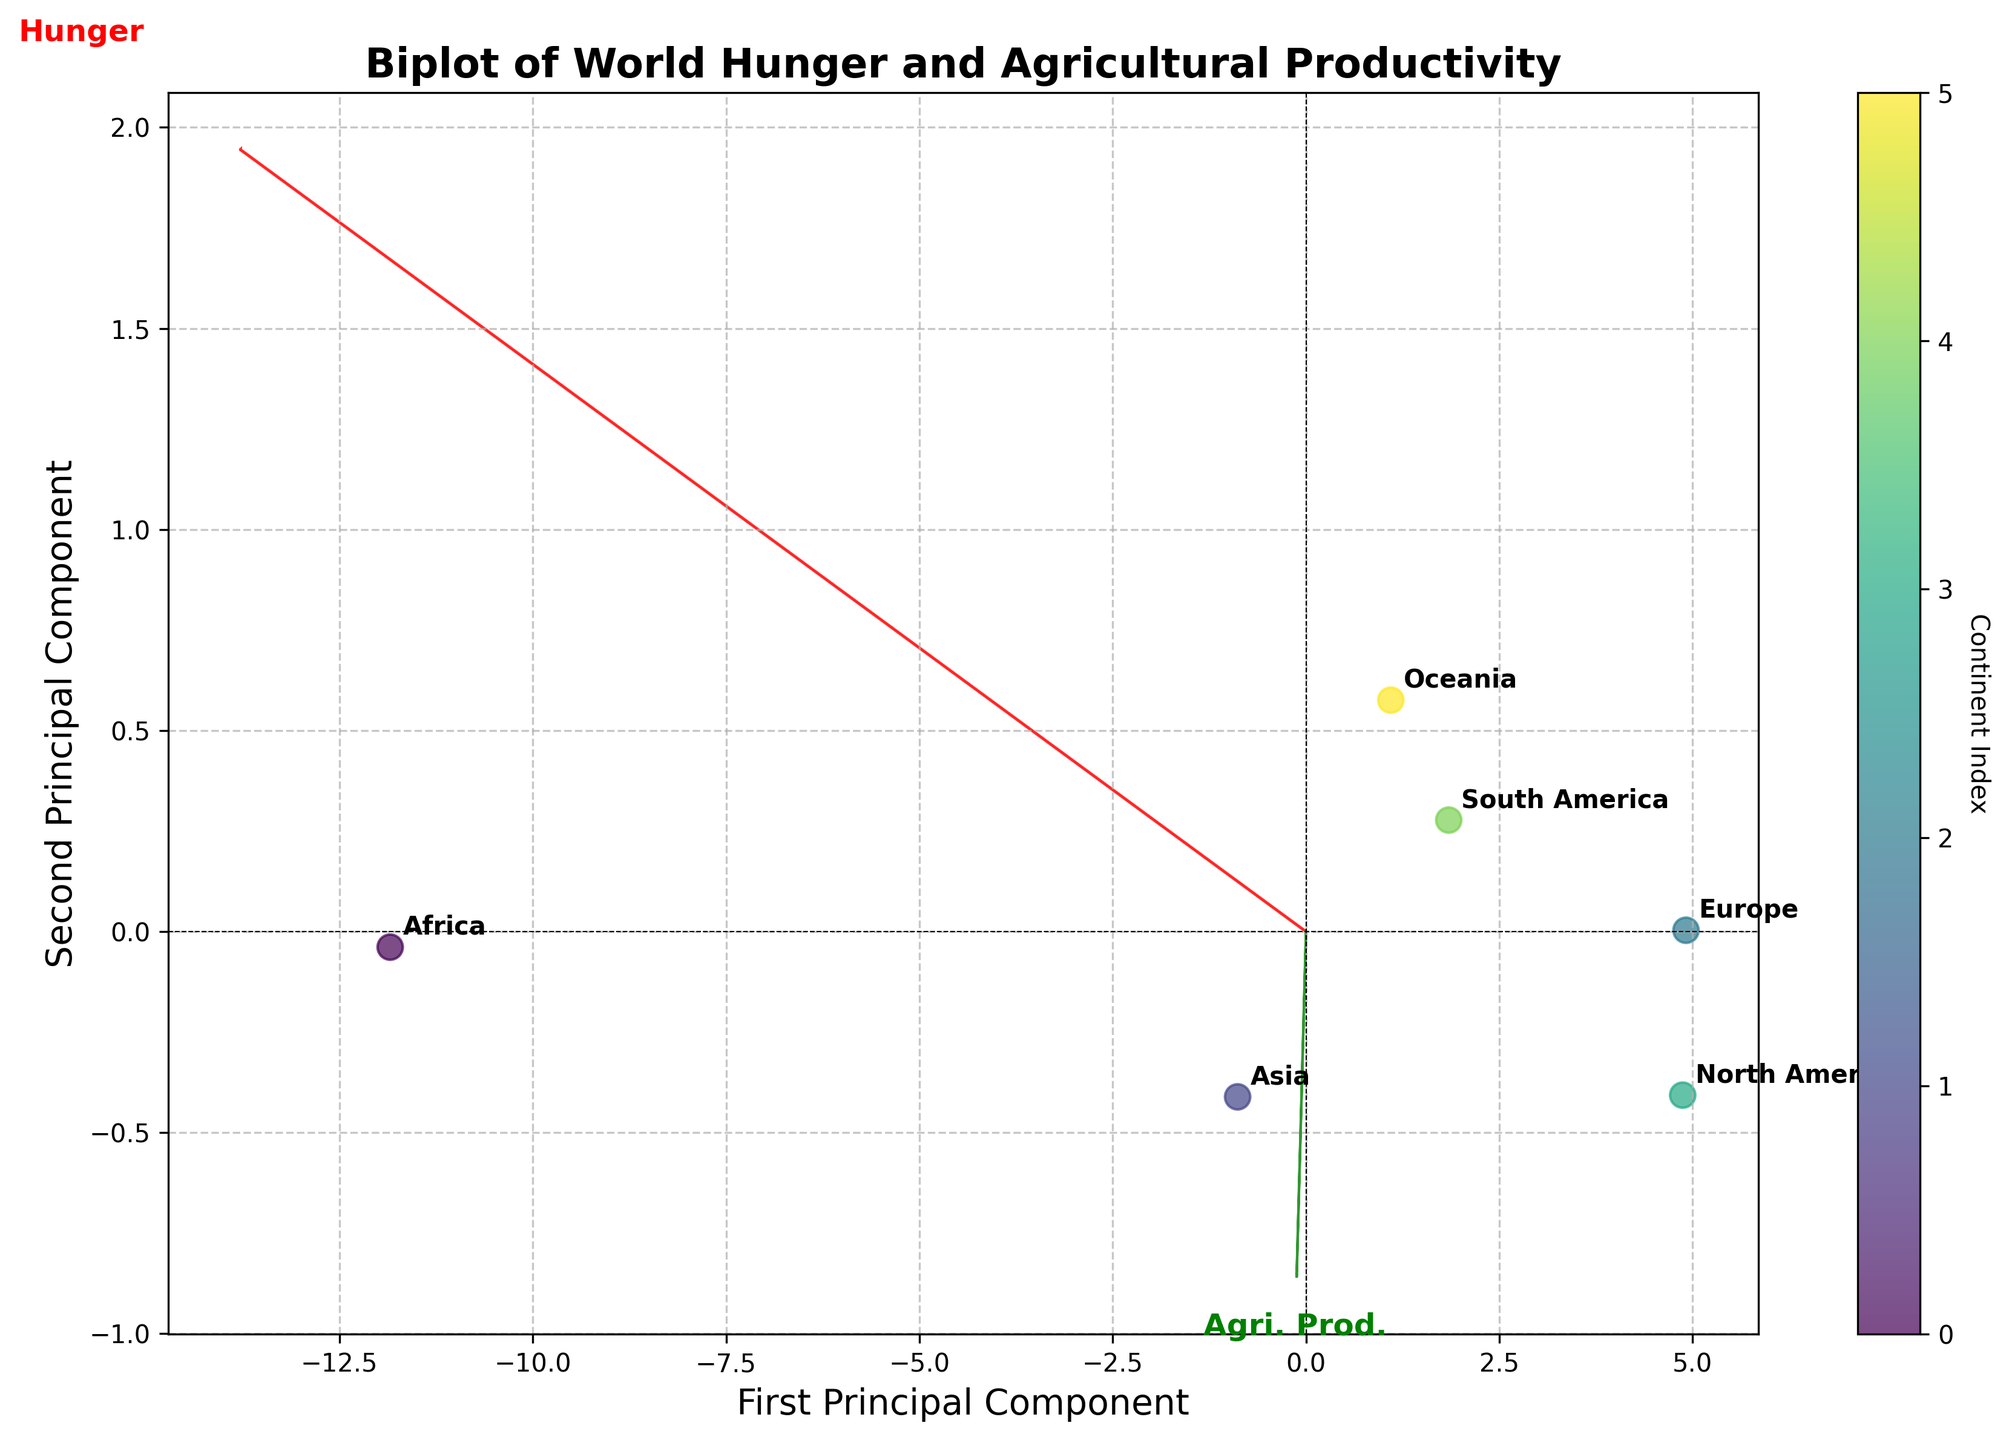How many continents are represented in the biplot? There are six data points in the scatter plot, each annotated with a continent label. Therefore, six continents are represented.
Answer: Six Which principal component explains the most variance in the data? The first principal component is always the one that explains the most variance in the data, as implied by its position on the x-axis.
Answer: First Principal Component Which continent has the lowest agricultural productivity? The position of the data points on the biplot shows that Africa is the farthest to the left along the "Agri. Prod." axis, indicating the lowest agricultural productivity.
Answer: Africa Which two features are represented by the vectors in the biplot? The arrows labeled "Hunger" and "Agri. Prod." represent the two features of the dataset. These arrows indicate loading directions of these variables.
Answer: Hunger and Agricultural Productivity If you walk along the 'Hunger' vector from the origin, which continent do you encounter first? Following the direction of the 'Hunger' vector from the origin, the first continent data point you come across is Africa.
Answer: Africa Which continent has the highest irrigation coverage and is this reflected in its position on the biplot? According to the biplot, Asia, which is positioned in the upper region indicating higher agricultural productivity, has the highest irrigation coverage.
Answer: Asia How does South America compare to Europe in terms of hunger prevalence based on the biplot? The difference in the positions of South America and Europe along the 'Hunger' vector shows that South America has a higher hunger prevalence compared to Europe.
Answer: South America has higher hunger prevalence than Europe What does the color of the scatter points represent? The color bar labeled 'Continent Index' indicates that the colors of the scatter points represent different continent indices, distinguishing each continent visually.
Answer: Continent Index Is there any continent where both hunger prevalence and agricultural productivity are above average? By identifying continents positioned in the upper-right quadrant relative to the origin on the biplot, it's clear that Asia is the only continent where both features are above average.
Answer: Asia What can be inferred about Oceania based on its position on the biplot? Oceania's position near the center suggests average values for both hunger prevalence and agricultural productivity compared to other continents.
Answer: Oceania is near-average 